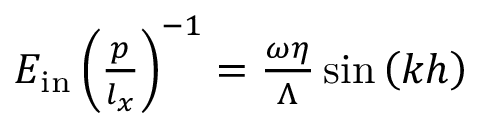<formula> <loc_0><loc_0><loc_500><loc_500>\begin{array} { r } { E _ { i n } \left ( \frac { p } { l _ { x } } \right ) ^ { - 1 } = \frac { \omega \eta } { \Lambda } \sin \left ( k h \right ) } \end{array}</formula> 